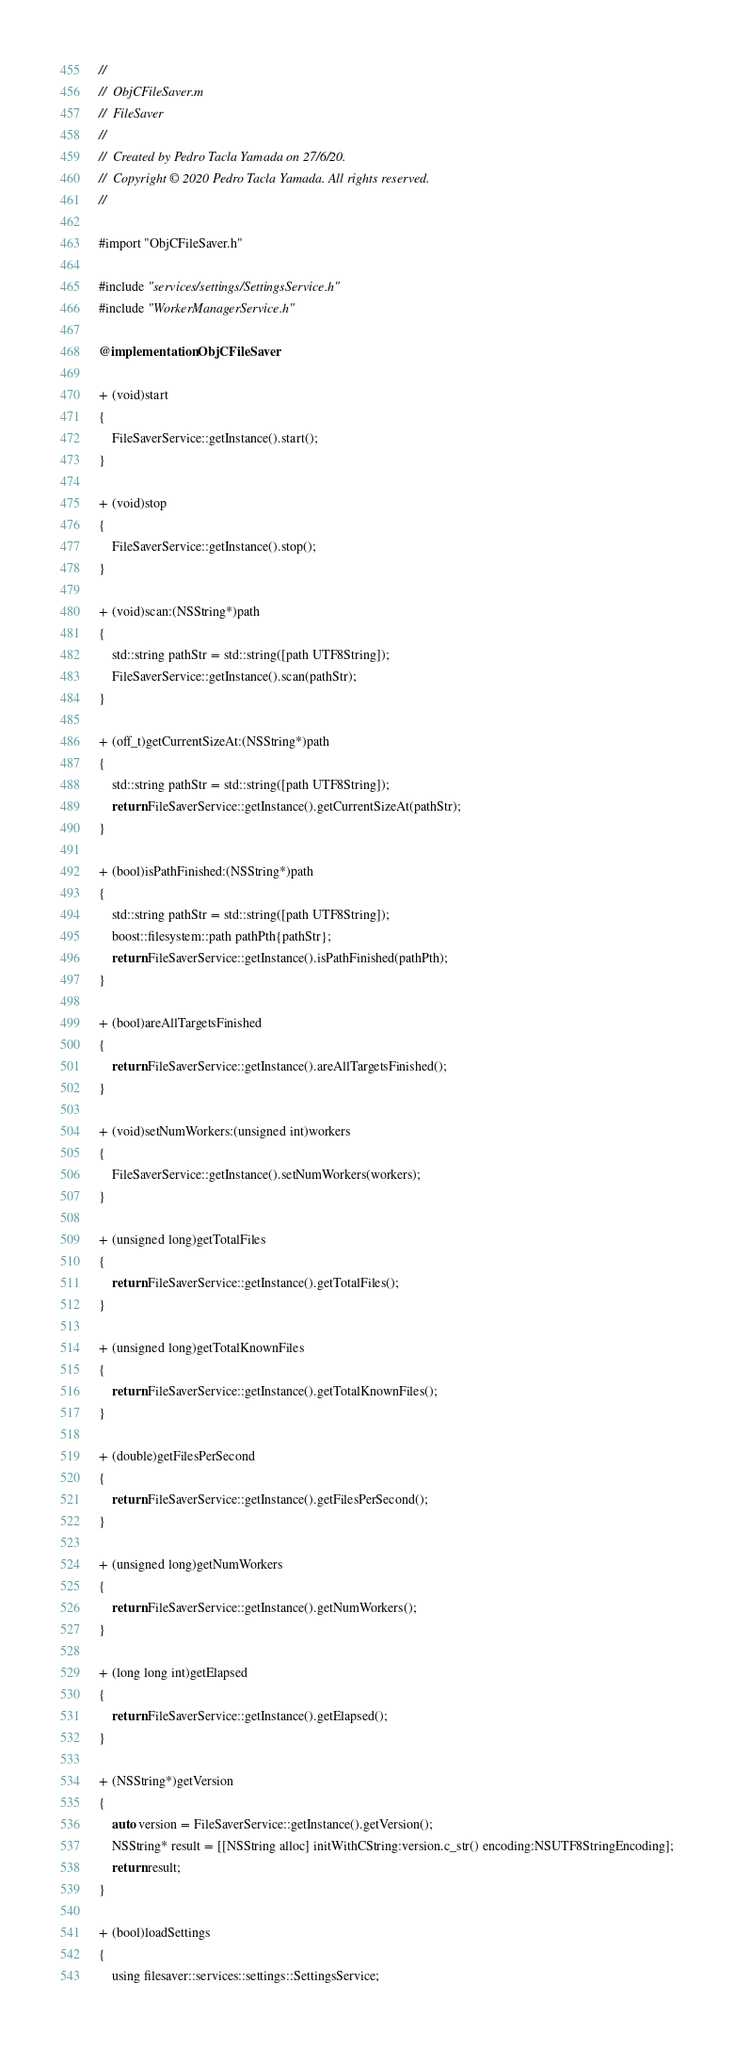Convert code to text. <code><loc_0><loc_0><loc_500><loc_500><_ObjectiveC_>//
//  ObjCFileSaver.m
//  FileSaver
//
//  Created by Pedro Tacla Yamada on 27/6/20.
//  Copyright © 2020 Pedro Tacla Yamada. All rights reserved.
//

#import "ObjCFileSaver.h"

#include "services/settings/SettingsService.h"
#include "WorkerManagerService.h"

@implementation ObjCFileSaver

+ (void)start
{
    FileSaverService::getInstance().start();
}

+ (void)stop
{
    FileSaverService::getInstance().stop();
}

+ (void)scan:(NSString*)path
{
    std::string pathStr = std::string([path UTF8String]);
    FileSaverService::getInstance().scan(pathStr);
}

+ (off_t)getCurrentSizeAt:(NSString*)path
{
    std::string pathStr = std::string([path UTF8String]);
    return FileSaverService::getInstance().getCurrentSizeAt(pathStr);
}

+ (bool)isPathFinished:(NSString*)path
{
    std::string pathStr = std::string([path UTF8String]);
    boost::filesystem::path pathPth{pathStr};
    return FileSaverService::getInstance().isPathFinished(pathPth);
}

+ (bool)areAllTargetsFinished
{
    return FileSaverService::getInstance().areAllTargetsFinished();
}

+ (void)setNumWorkers:(unsigned int)workers
{
    FileSaverService::getInstance().setNumWorkers(workers);
}

+ (unsigned long)getTotalFiles
{
    return FileSaverService::getInstance().getTotalFiles();
}

+ (unsigned long)getTotalKnownFiles
{
    return FileSaverService::getInstance().getTotalKnownFiles();
}

+ (double)getFilesPerSecond
{
    return FileSaverService::getInstance().getFilesPerSecond();
}

+ (unsigned long)getNumWorkers
{
    return FileSaverService::getInstance().getNumWorkers();
}

+ (long long int)getElapsed
{
    return FileSaverService::getInstance().getElapsed();
}

+ (NSString*)getVersion
{
    auto version = FileSaverService::getInstance().getVersion();
    NSString* result = [[NSString alloc] initWithCString:version.c_str() encoding:NSUTF8StringEncoding];
    return result;
}

+ (bool)loadSettings
{
    using filesaver::services::settings::SettingsService;</code> 